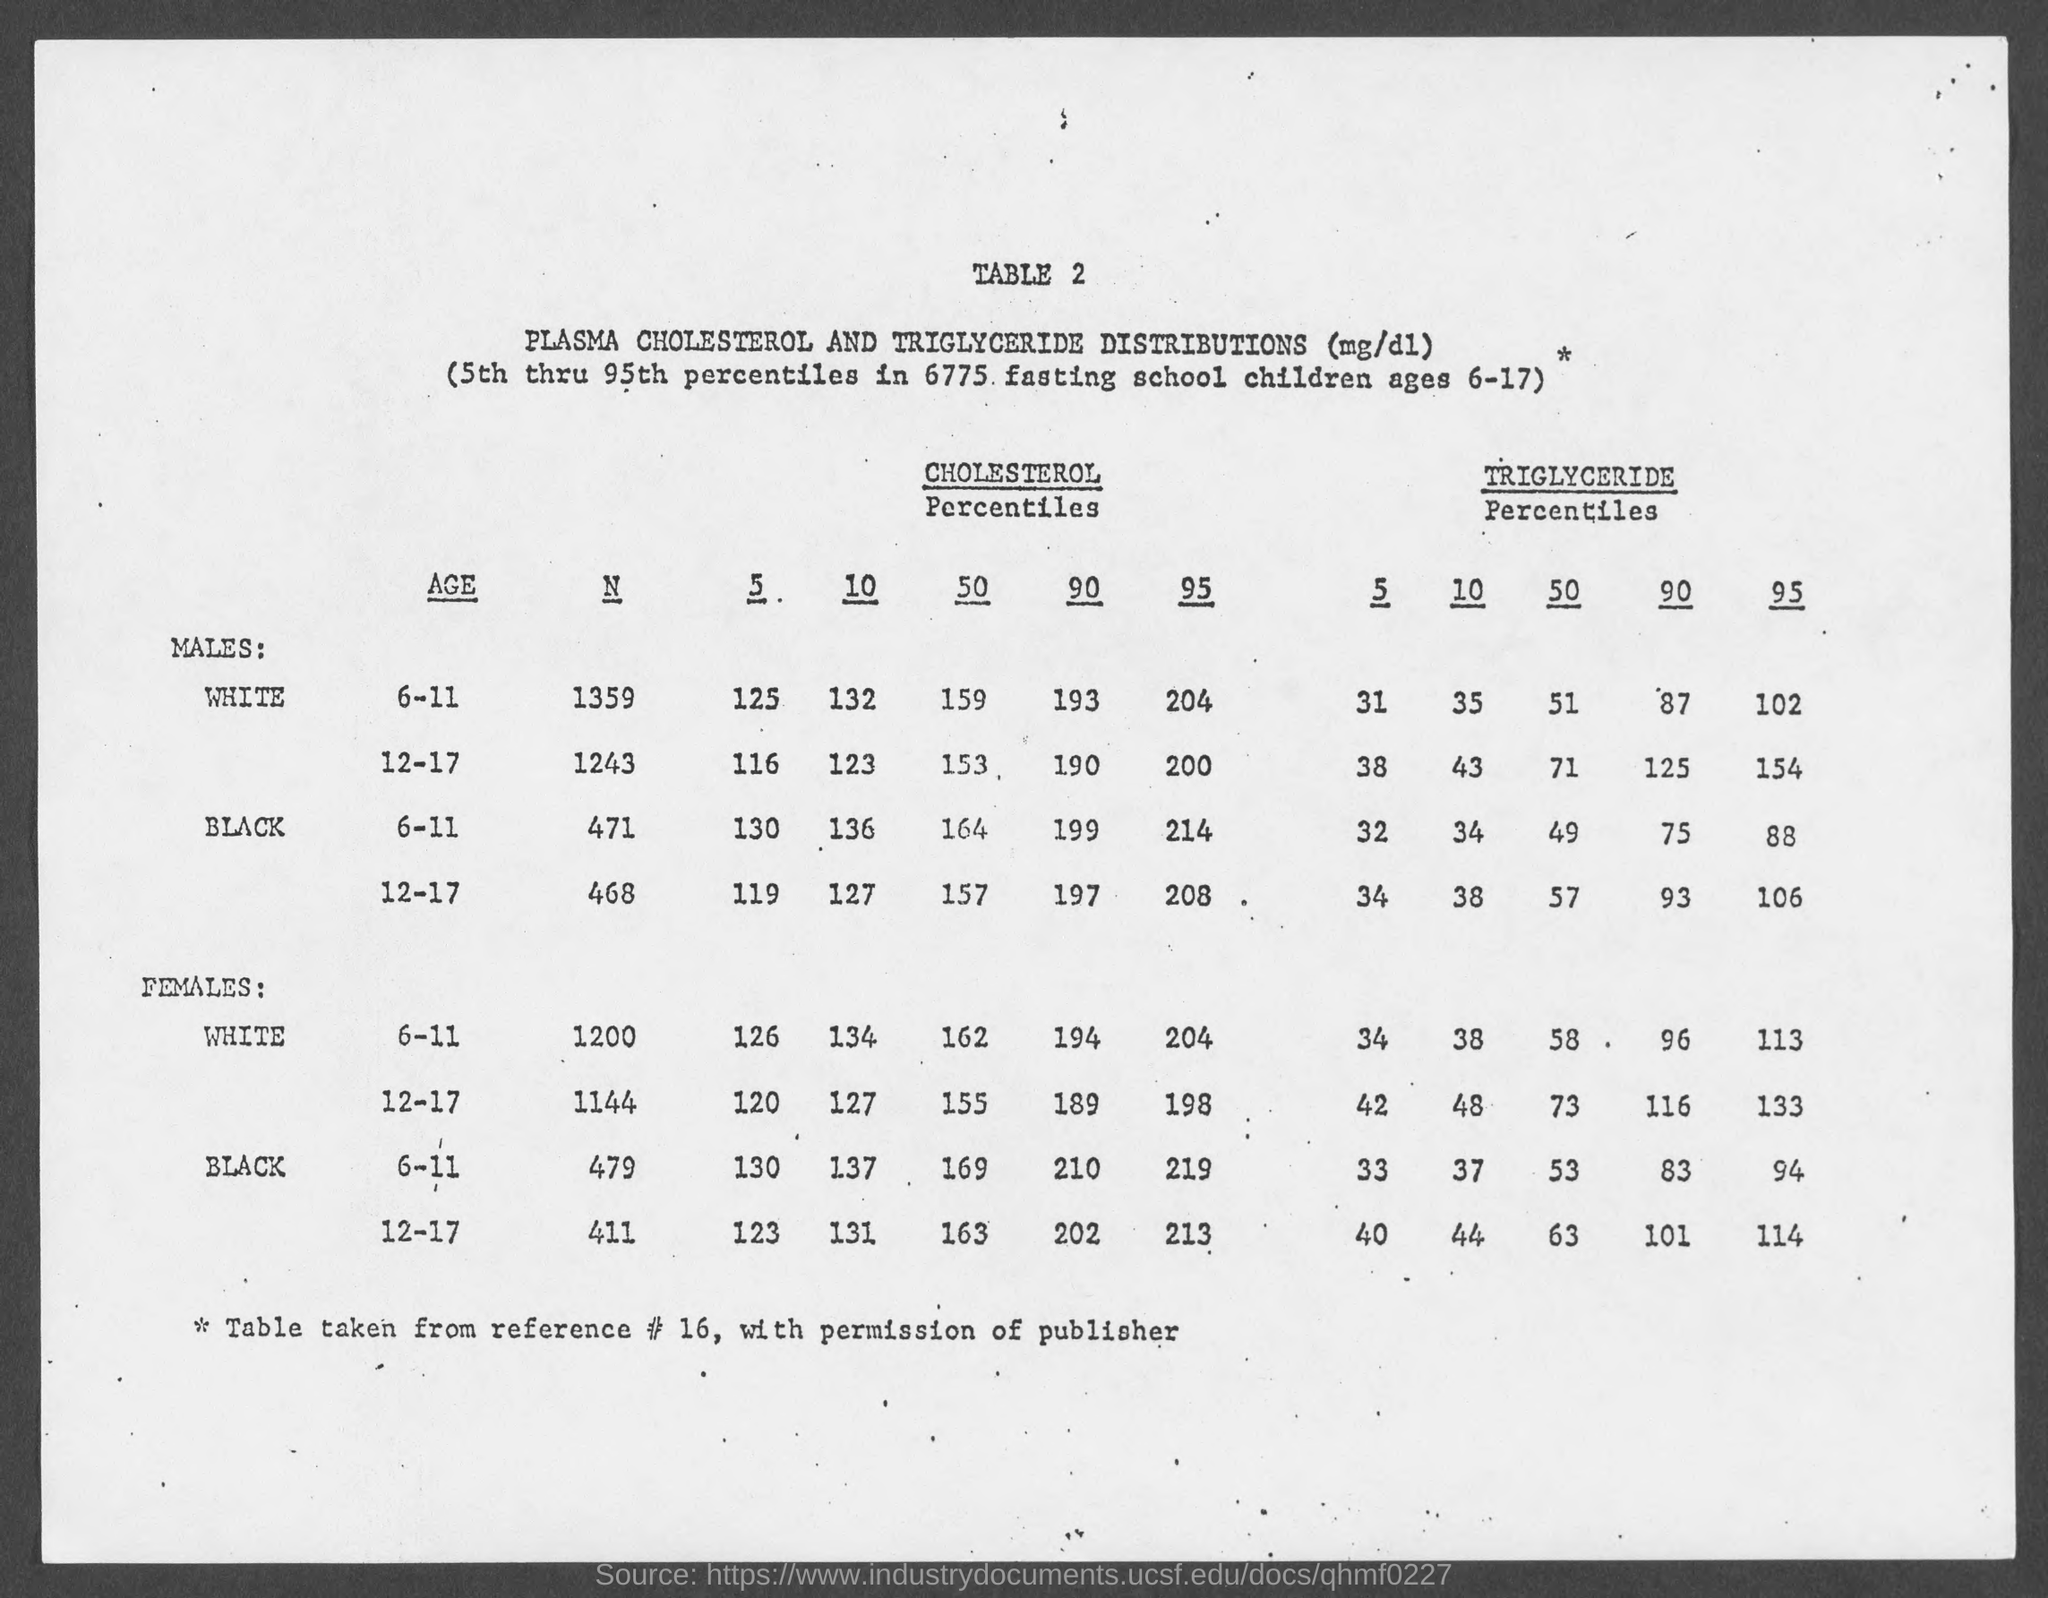What is the table no.?
Ensure brevity in your answer.  Table 2. 